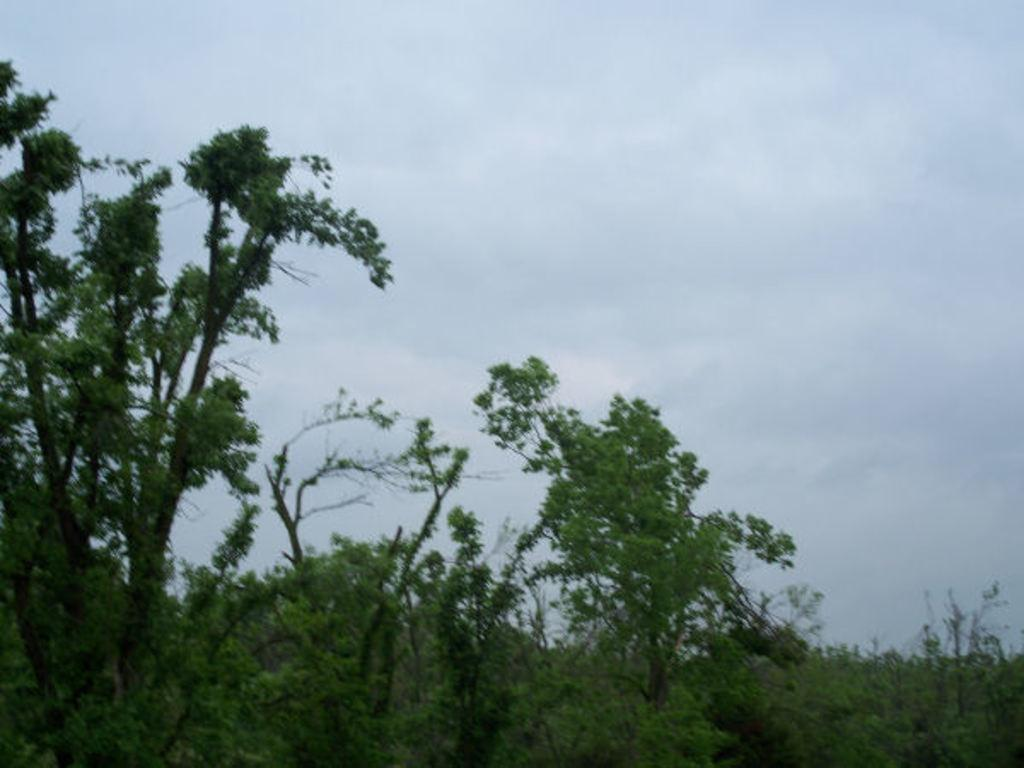What type of vegetation can be seen in the image? There are trees in the image. What is the condition of the sky in the image? The sky is cloudy in the image. What color is the crayon used to draw the texture of the trees in the image? There is no crayon or drawing present in the image; it is a photograph of real trees. 